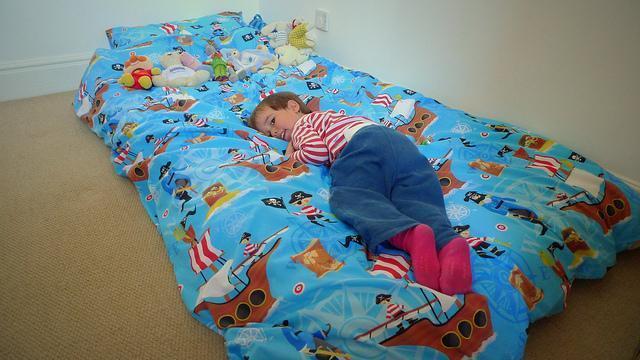How many beds can you see?
Give a very brief answer. 1. 